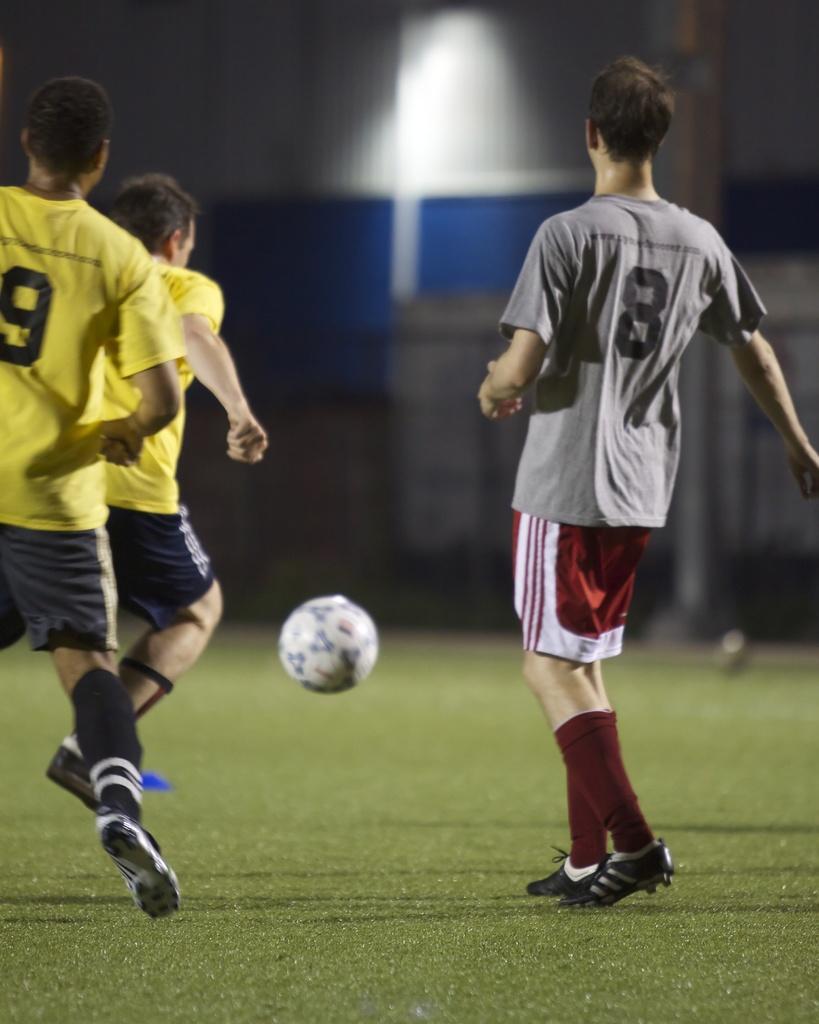Could you give a brief overview of what you see in this image? This picture we can see people playing football. At the bottom there is grass. In the background there is a building and light. 